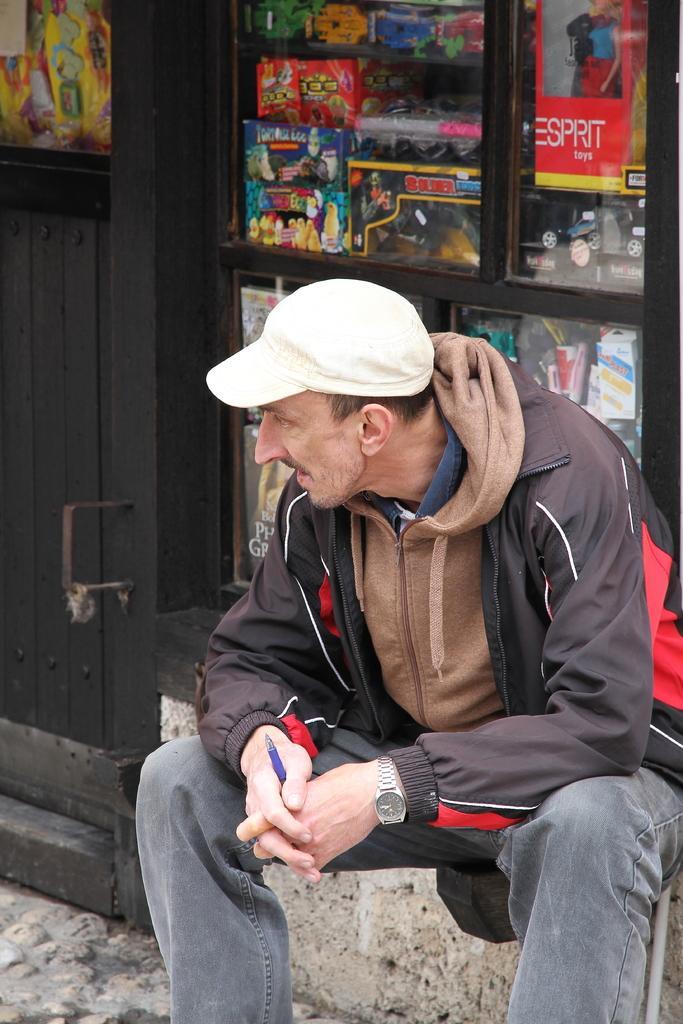Can you describe this image briefly? In the image we can see a man sitting, wearing clothes, wrist watch, cap and the man is holding a pen in hand. Here we can see the door and it looks like a shop. 